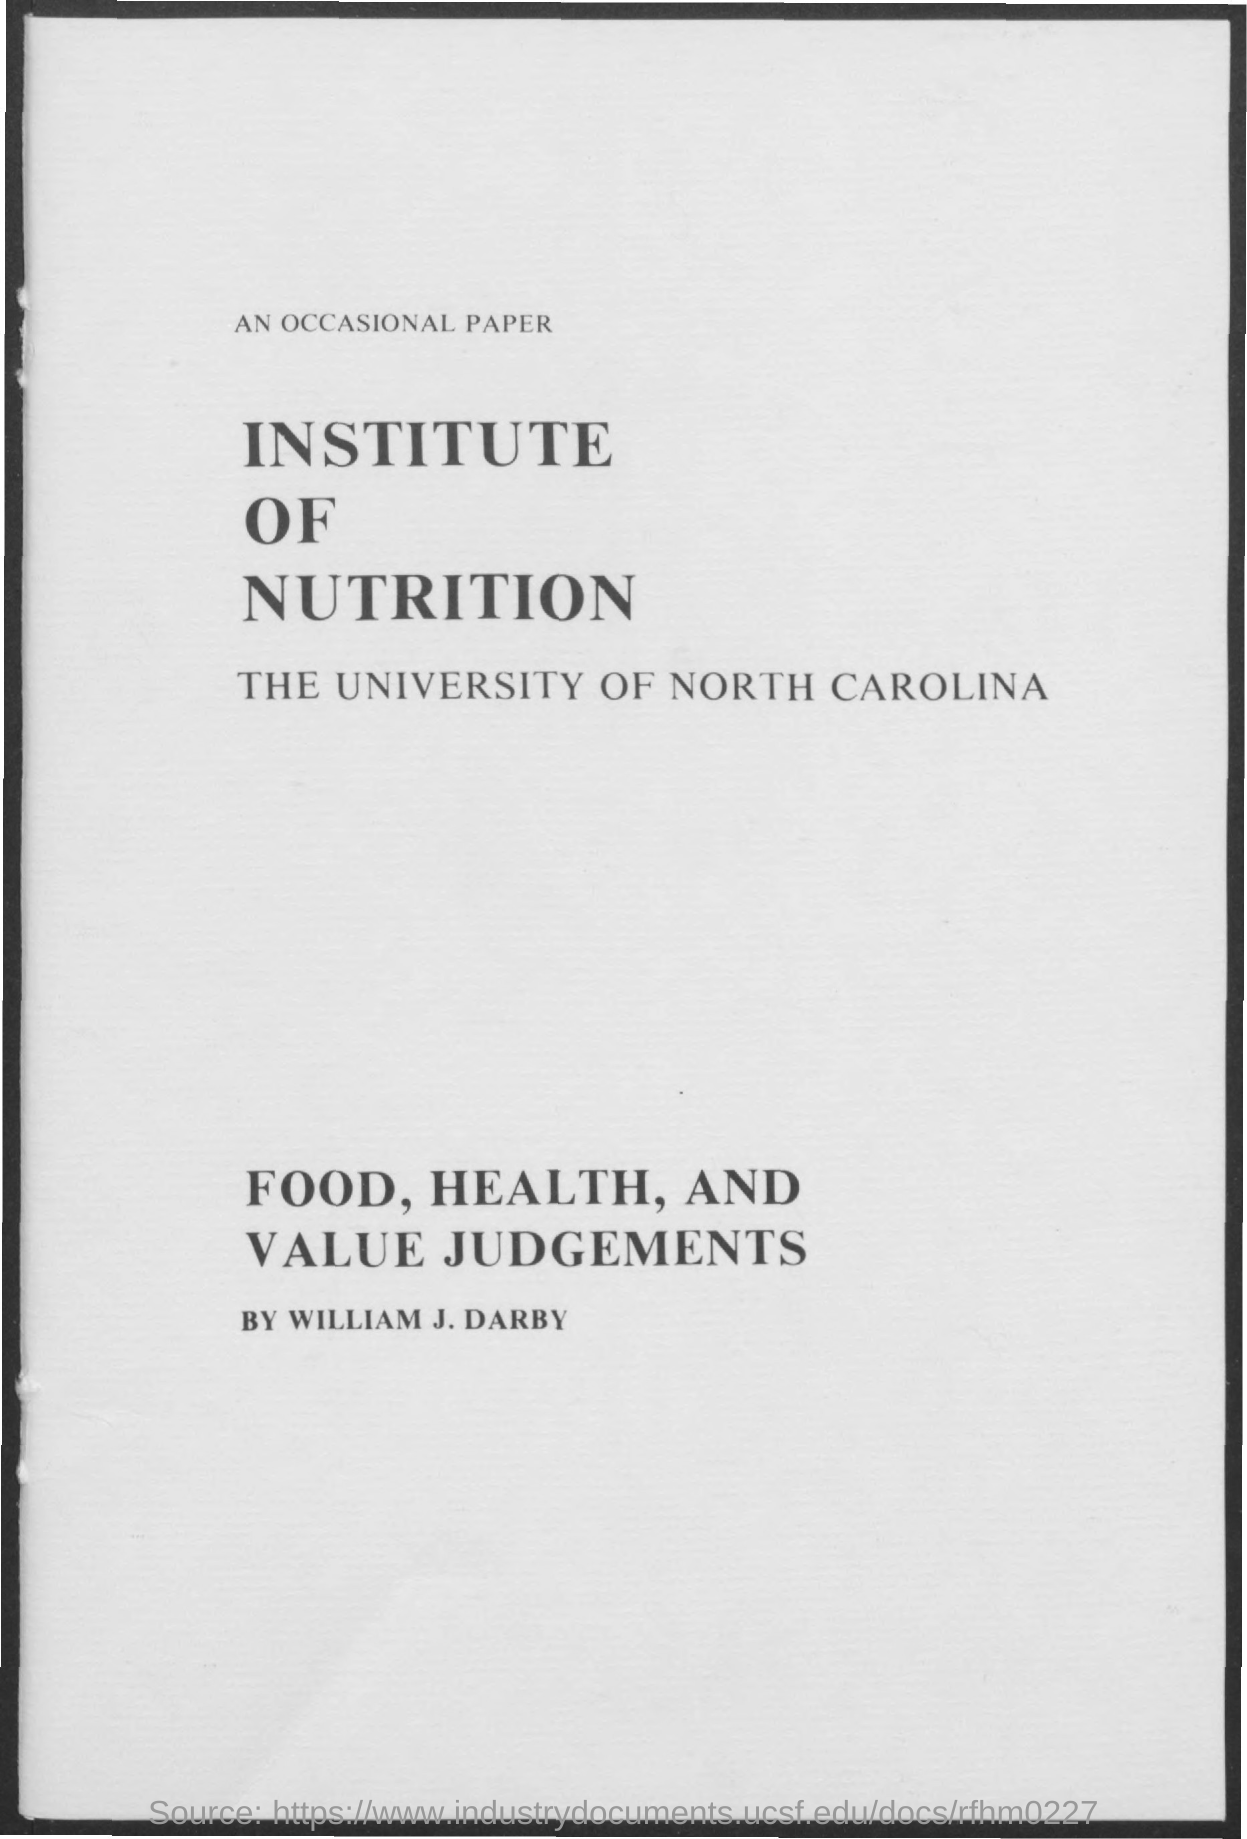Indicate a few pertinent items in this graphic. The University of North Carolina is named. 